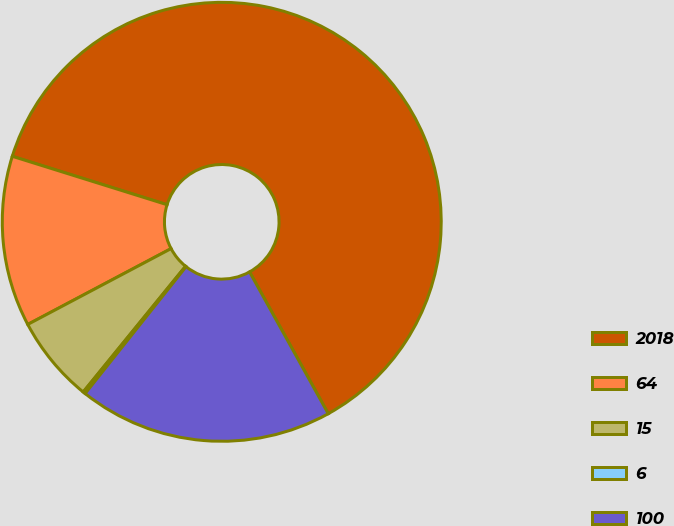<chart> <loc_0><loc_0><loc_500><loc_500><pie_chart><fcel>2018<fcel>64<fcel>15<fcel>6<fcel>100<nl><fcel>62.11%<fcel>12.57%<fcel>6.38%<fcel>0.18%<fcel>18.76%<nl></chart> 